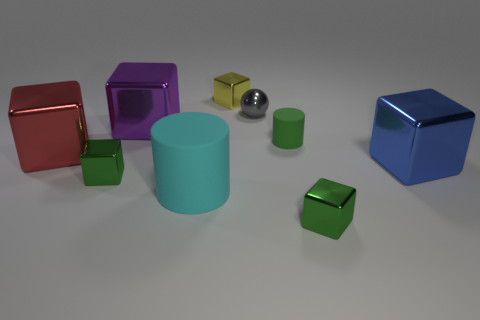How many other objects are the same color as the tiny metal sphere?
Offer a terse response. 0. How many things are tiny objects that are left of the small sphere or brown shiny objects?
Provide a succinct answer. 2. There is a small cylinder; is its color the same as the small metallic block on the right side of the small green rubber cylinder?
Your response must be concise. Yes. What is the size of the rubber cylinder to the right of the tiny shiny cube that is behind the small sphere?
Provide a succinct answer. Small. How many objects are either big cyan objects or matte objects on the left side of the tiny yellow cube?
Your answer should be very brief. 1. There is a matte object that is behind the big matte object; is its shape the same as the tiny gray metallic thing?
Give a very brief answer. No. There is a green shiny block that is behind the small green block right of the green rubber cylinder; what number of large metal cubes are to the left of it?
Offer a terse response. 1. Is there any other thing that has the same shape as the small gray object?
Keep it short and to the point. No. What number of things are red metallic objects or shiny things?
Offer a terse response. 7. There is a small yellow thing; is its shape the same as the tiny green shiny thing that is to the right of the tiny ball?
Make the answer very short. Yes. 